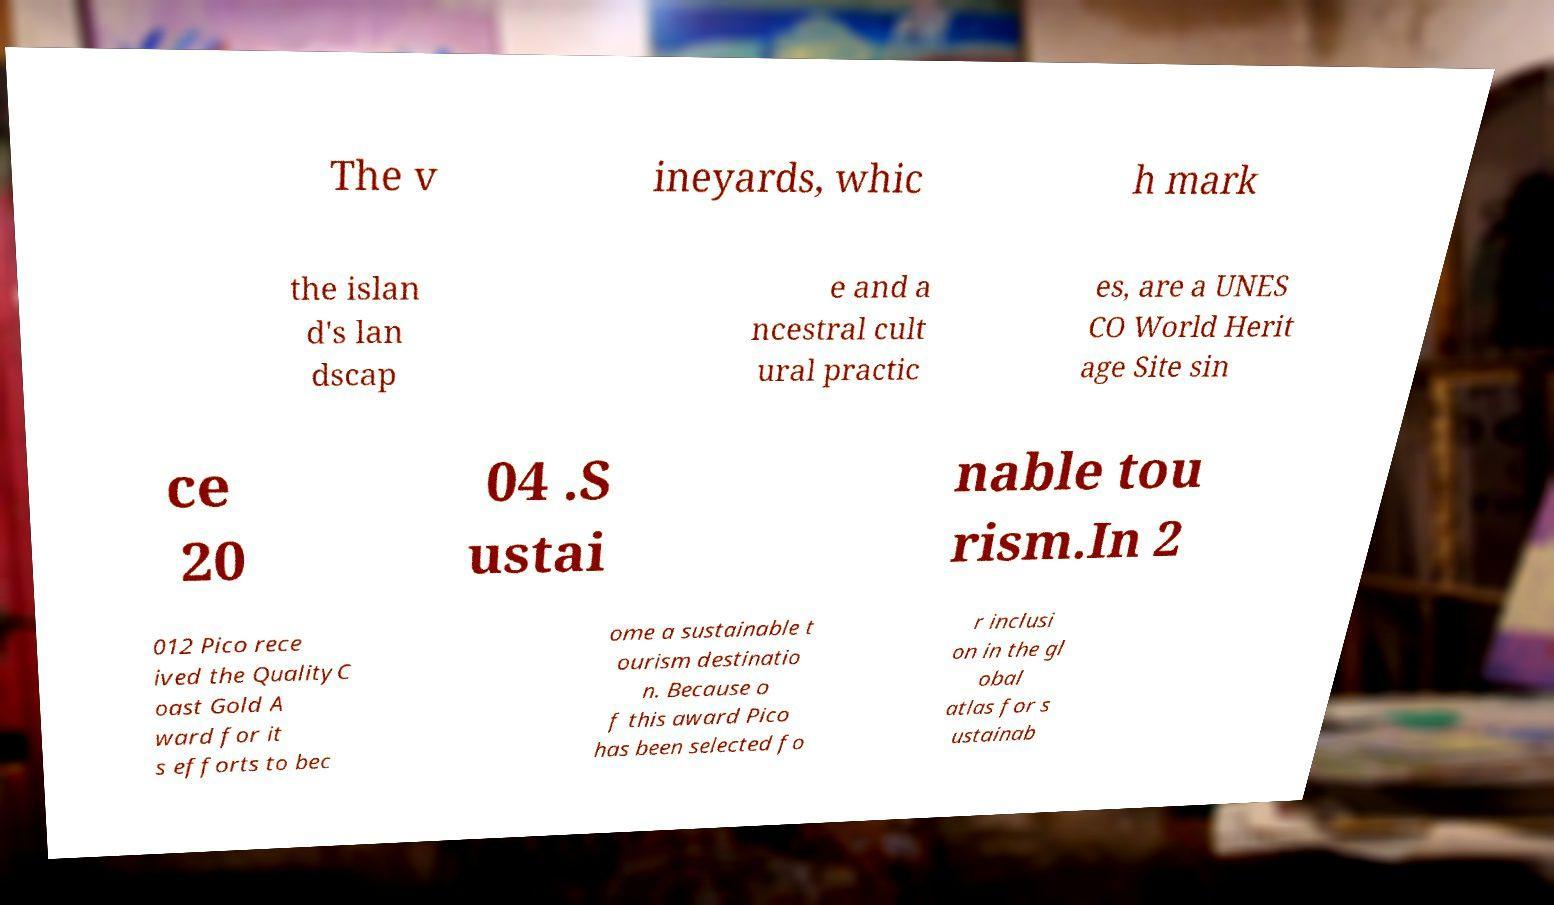I need the written content from this picture converted into text. Can you do that? The v ineyards, whic h mark the islan d's lan dscap e and a ncestral cult ural practic es, are a UNES CO World Herit age Site sin ce 20 04 .S ustai nable tou rism.In 2 012 Pico rece ived the QualityC oast Gold A ward for it s efforts to bec ome a sustainable t ourism destinatio n. Because o f this award Pico has been selected fo r inclusi on in the gl obal atlas for s ustainab 